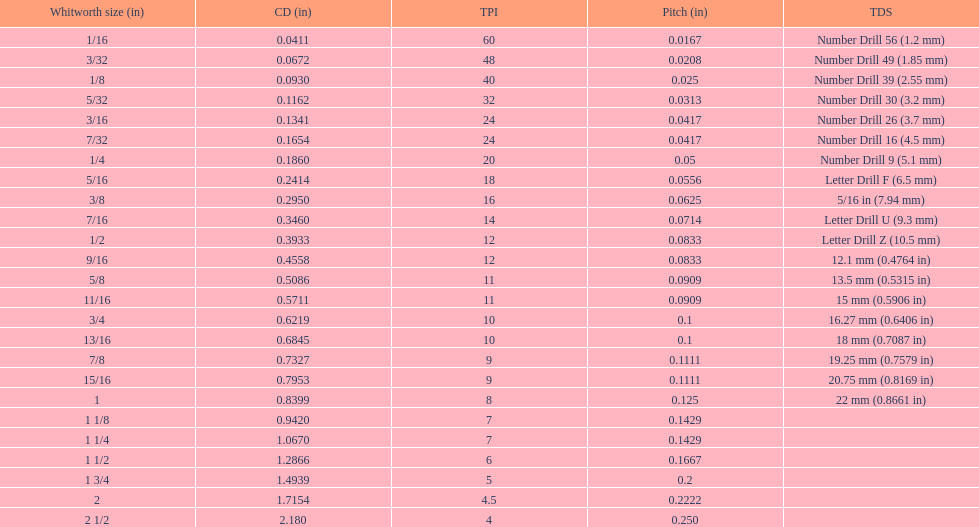How many threads per inch does a 9/16 have? 12. 